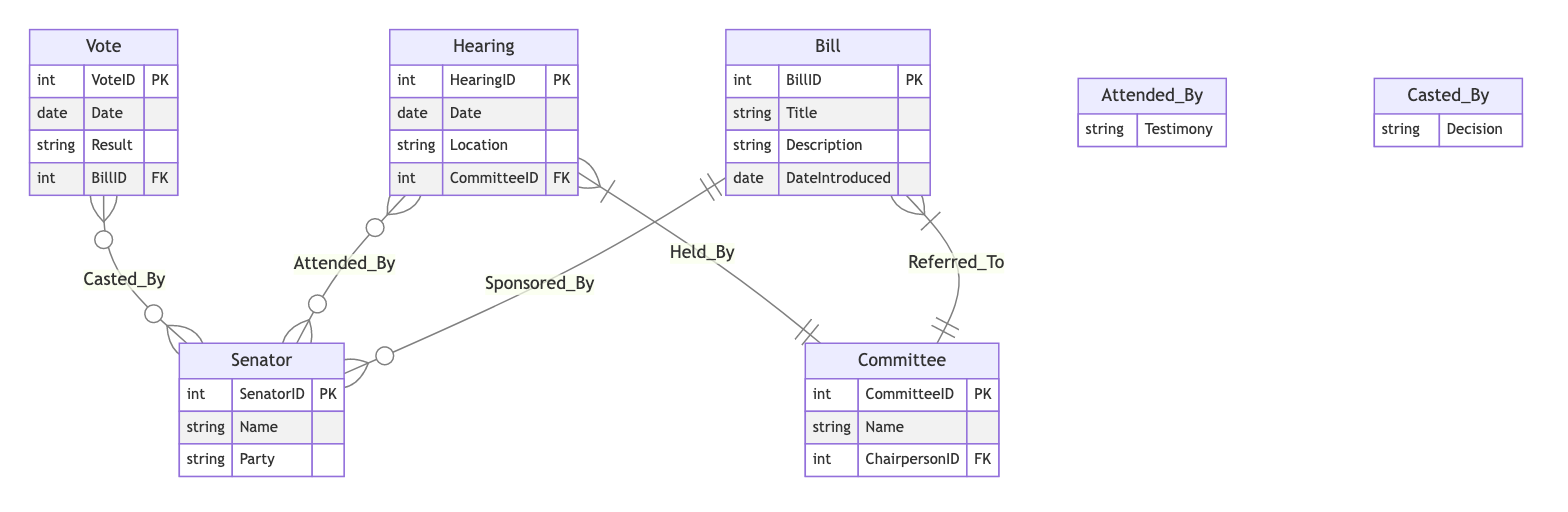What is the primary entity that represents proposed legislation? In the diagram, the entity that signifies proposed legislation is labeled "Bill." It contains attributes such as BillID, Title, Description, and DateIntroduced, indicating it is the central component of the legislative process.
Answer: Bill How many attributes does the Senator entity have? The Senator entity is detailed in the diagram with three identified attributes: SenatorID, Name, and Party. Thus, counting these attributes, the total is three.
Answer: 3 What relationship exists between the Bill and Committee entities? The Bill is related to the Committee through a Many-to-One relationship labeled "Referred_To." This indicates that multiple bills can be referred to one committee, showing how legislation moves through the senate.
Answer: Referred_To How many entities are depicted in the diagram? The diagram includes five primary entities: Bill, Senator, Committee, Hearing, and Vote. To find the total, simply count each of these distinct entities present.
Answer: 5 What attribute describes the outcome of a Vote? In the Vote entity, the attribute that describes the outcome is labeled "Result." This attribute indicates whether the vote was successful or unsuccessful, giving insight into the legislative process's results.
Answer: Result How many Senators can attend a Hearing? The relationship between Hearing and Senator entities is defined as Many-to-Many, meaning that multiple Senators can attend a single Hearing and vice versa. This suggests flexibility in who can participate in the legislative discussions held during hearings.
Answer: Many Which entity has a foreign key related to the Committee? The Bill entity contains a foreign key that pertains to the Committee, specifically through the relationship "Referred_To." This foreign key indicates the Committee responsible for the Bill in question.
Answer: Committee What is the significance of the relationship labeled "Attended_By"? The "Attended_By" relationship represents a Many-to-Many connection between Senators and Hearings, which allows for multiple Senators to attend various Hearings and gives them the opportunity to provide testimony, facilitating discussion on the proposed legislation.
Answer: Attended_By 